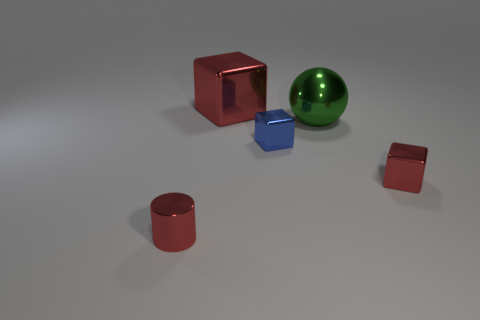Subtract all red cubes. How many cubes are left? 1 Add 2 tiny brown matte cylinders. How many objects exist? 7 Subtract all red cubes. How many cubes are left? 1 Subtract all cylinders. How many objects are left? 4 Subtract 1 cylinders. How many cylinders are left? 0 Subtract all purple cubes. Subtract all green balls. How many cubes are left? 3 Subtract all gray cubes. How many purple spheres are left? 0 Subtract all purple matte cylinders. Subtract all large spheres. How many objects are left? 4 Add 4 big red metallic things. How many big red metallic things are left? 5 Add 3 red shiny balls. How many red shiny balls exist? 3 